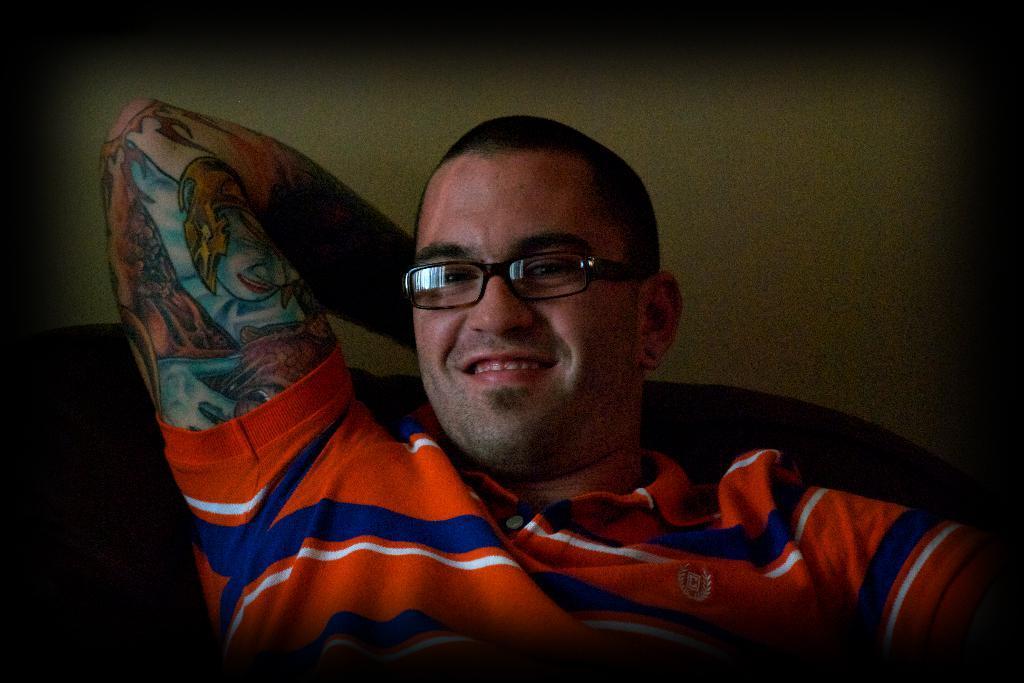How would you summarize this image in a sentence or two? In this image we can see a person smiling. Behind the person we can see a wall. On the personal hand, we can see a tattoo. 